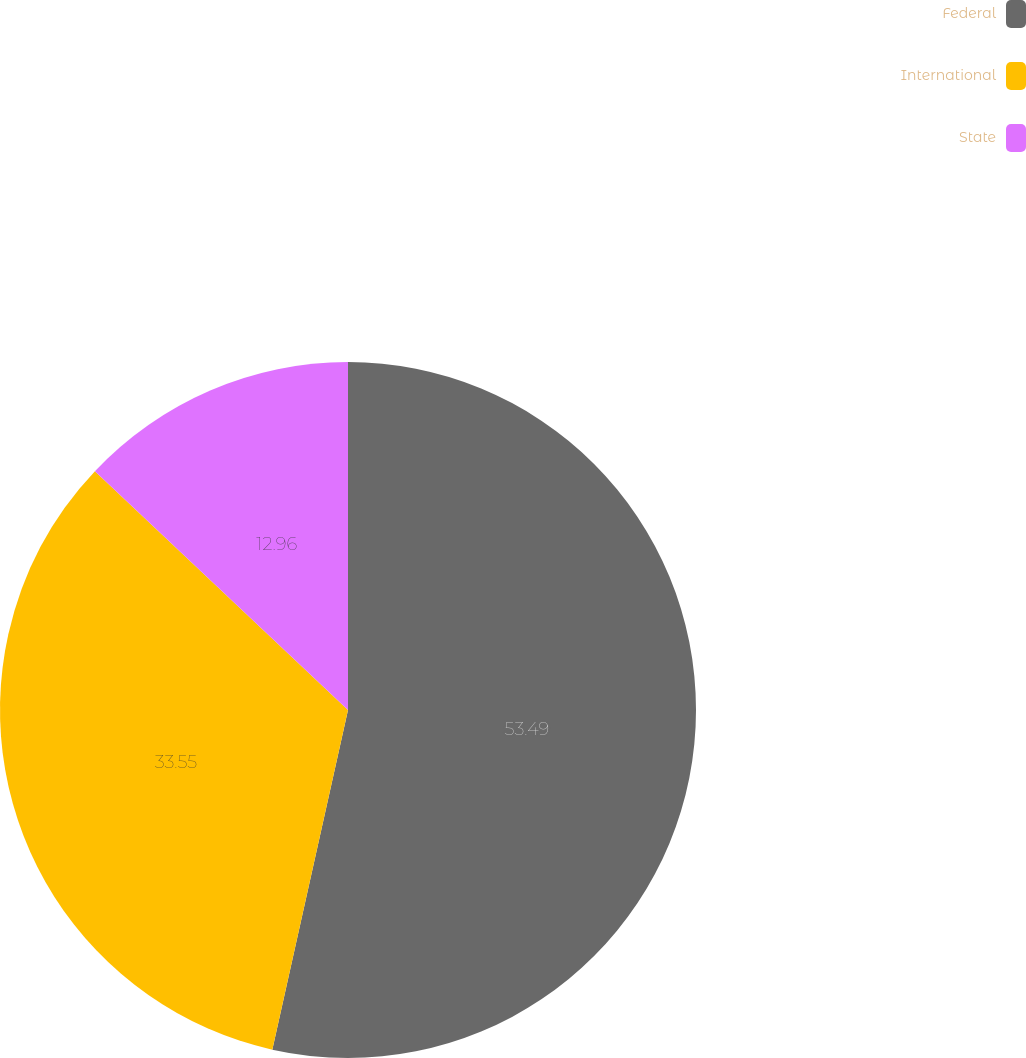<chart> <loc_0><loc_0><loc_500><loc_500><pie_chart><fcel>Federal<fcel>International<fcel>State<nl><fcel>53.49%<fcel>33.55%<fcel>12.96%<nl></chart> 